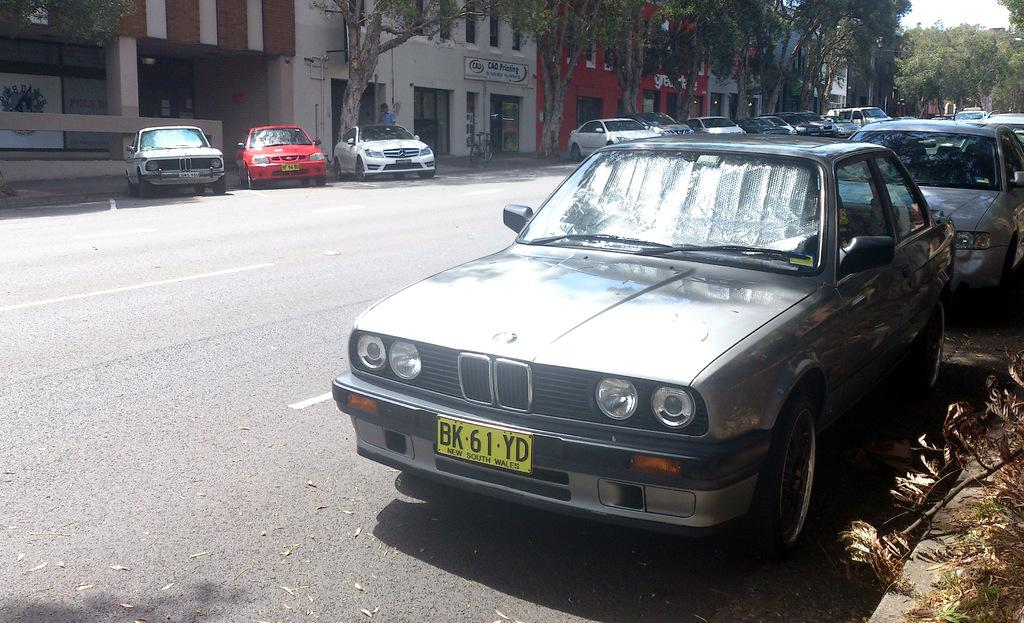What can be seen on the right side of the image? There are cars on the right side of the image. What can be seen on the left side of the image? There are cars on the left side of the image. What type of vegetation is visible in the top right side of the image? There are trees in the top right side of the image. What type of structures are visible at the top side of the image? There are buildings at the top side of the image. What type of sheet is being used to cover the cars in the image? There is no sheet present in the image; the cars are not covered. What type of sticks can be seen in the image? There are no sticks present in the image. 